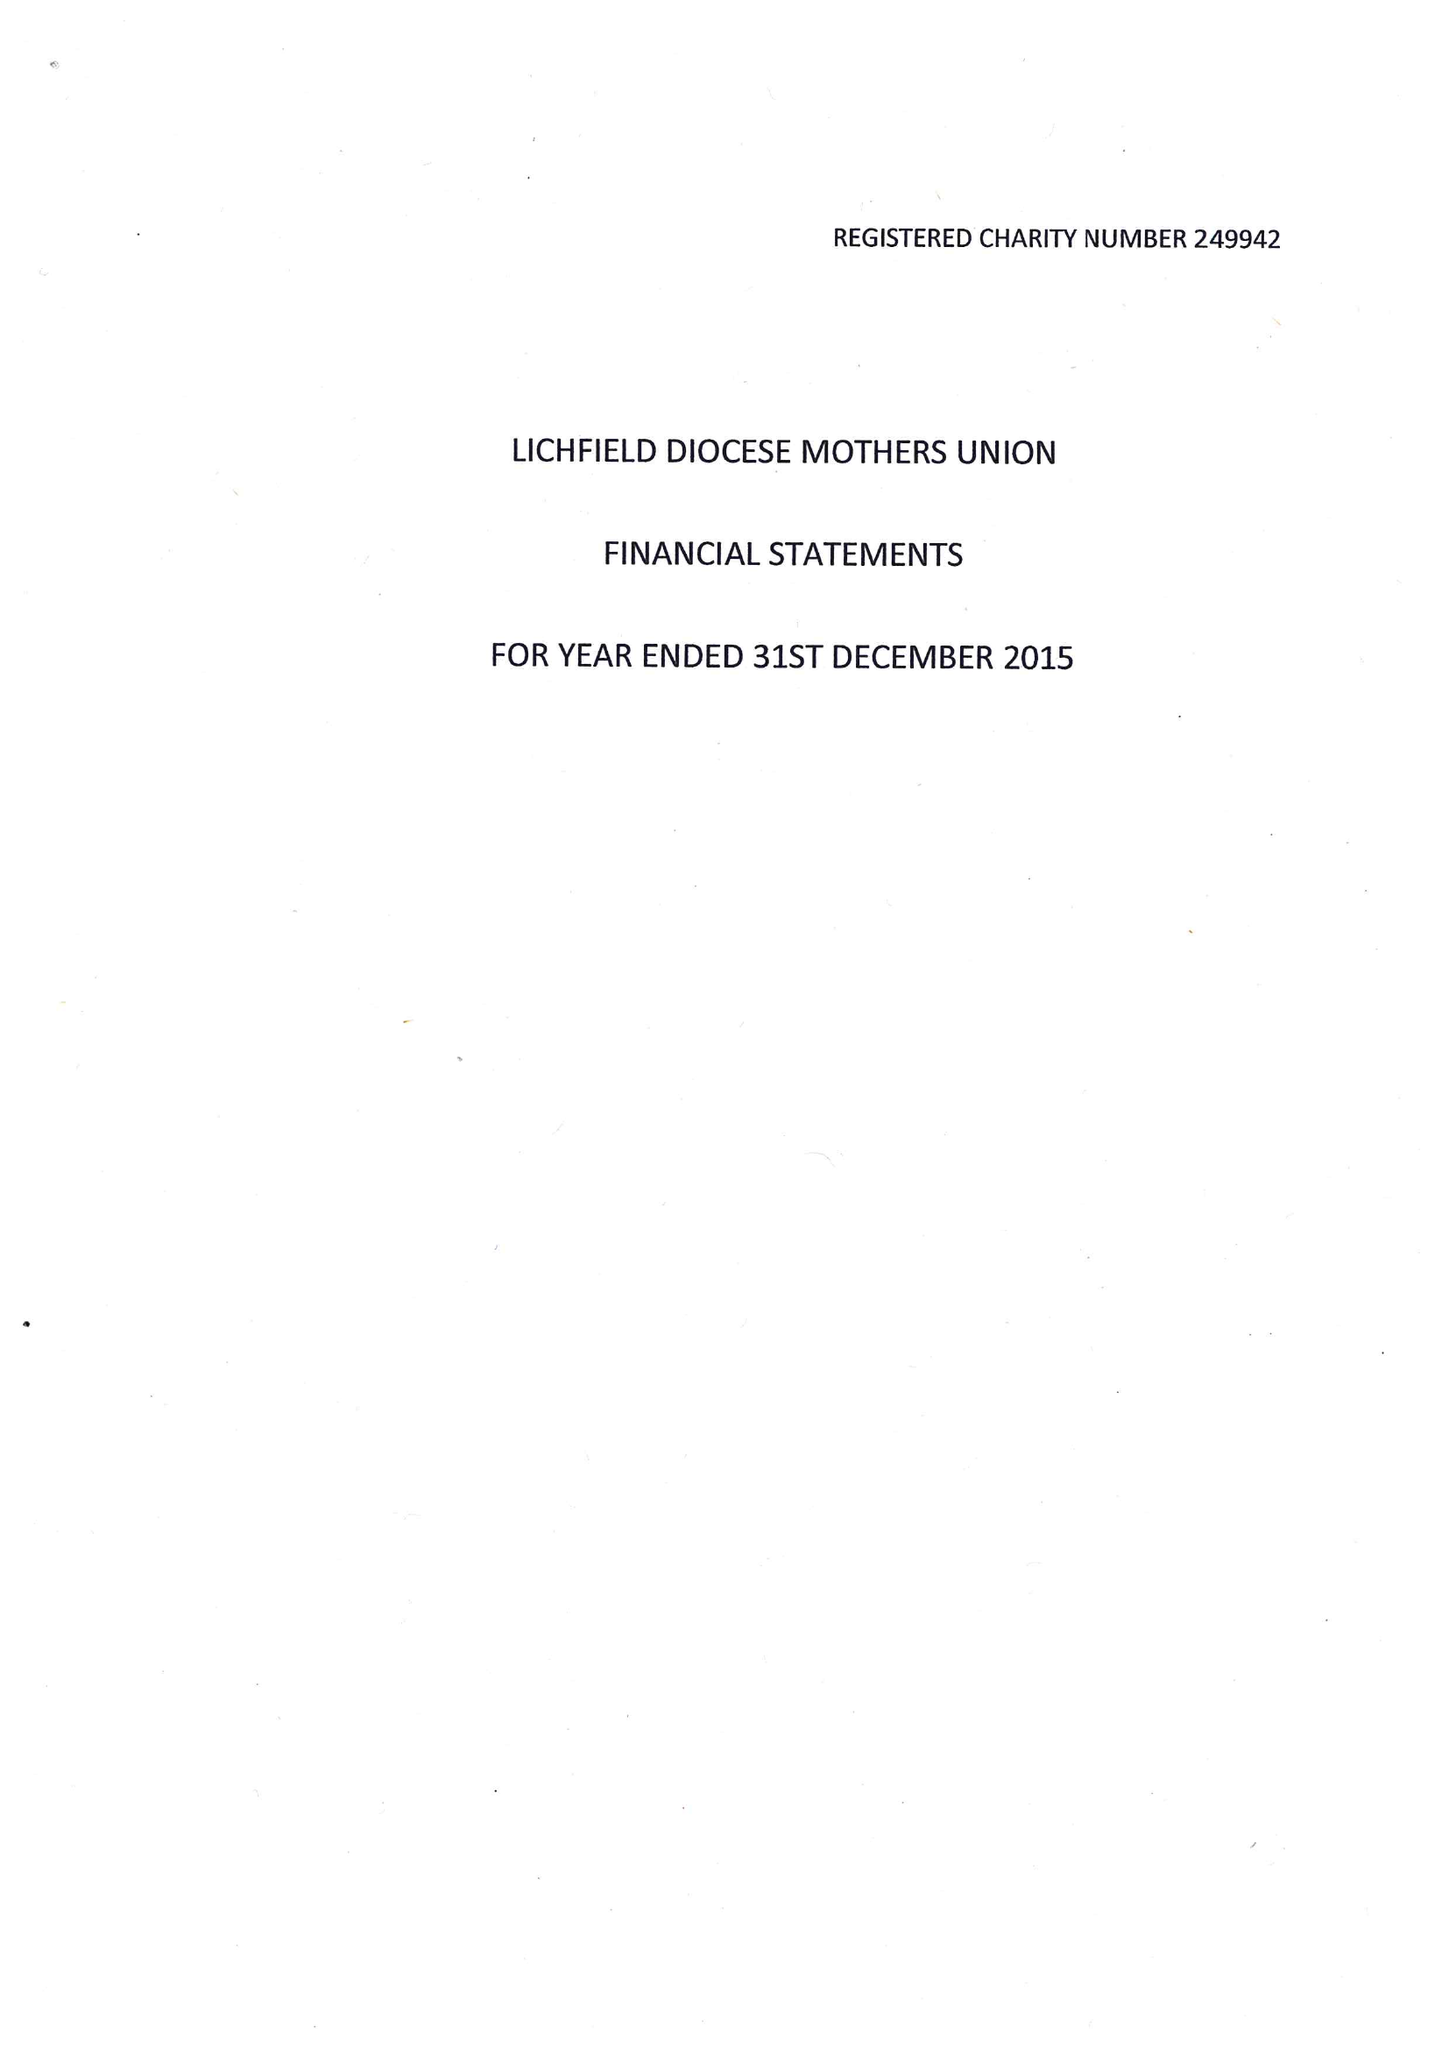What is the value for the address__postcode?
Answer the question using a single word or phrase. WS13 8EB 